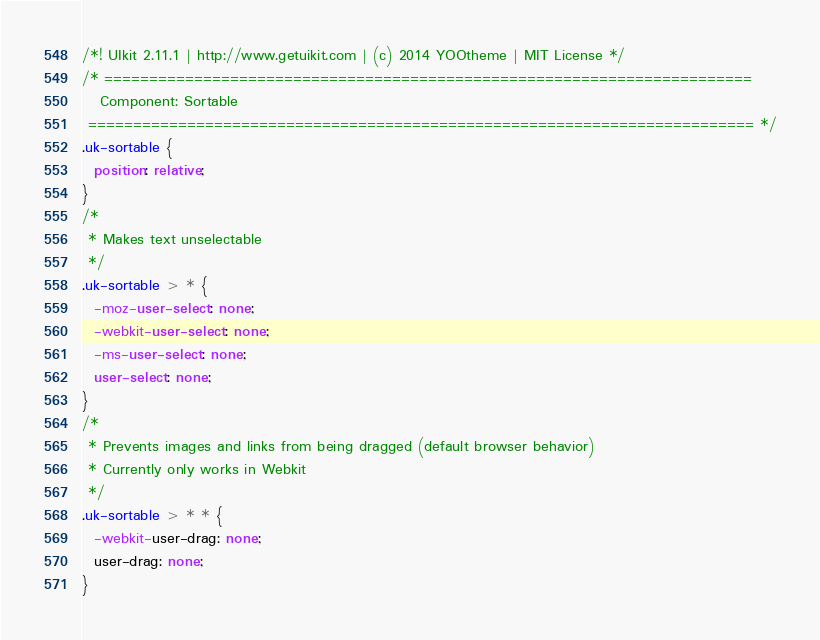<code> <loc_0><loc_0><loc_500><loc_500><_CSS_>/*! UIkit 2.11.1 | http://www.getuikit.com | (c) 2014 YOOtheme | MIT License */
/* ========================================================================
   Component: Sortable
 ========================================================================== */
.uk-sortable {
  position: relative;
}
/*
 * Makes text unselectable
 */
.uk-sortable > * {
  -moz-user-select: none;
  -webkit-user-select: none;
  -ms-user-select: none;
  user-select: none;
}
/*
 * Prevents images and links from being dragged (default browser behavior)
 * Currently only works in Webkit
 */
.uk-sortable > * * {
  -webkit-user-drag: none;
  user-drag: none;
}</code> 